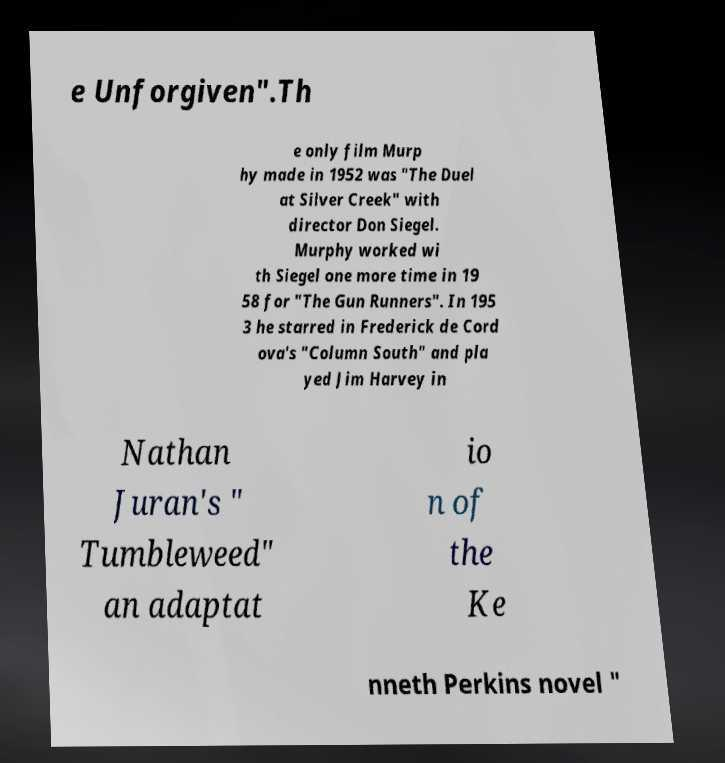Please read and relay the text visible in this image. What does it say? e Unforgiven".Th e only film Murp hy made in 1952 was "The Duel at Silver Creek" with director Don Siegel. Murphy worked wi th Siegel one more time in 19 58 for "The Gun Runners". In 195 3 he starred in Frederick de Cord ova's "Column South" and pla yed Jim Harvey in Nathan Juran's " Tumbleweed" an adaptat io n of the Ke nneth Perkins novel " 